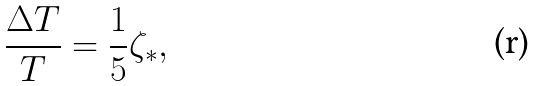<formula> <loc_0><loc_0><loc_500><loc_500>\frac { \Delta T } { T } = \frac { 1 } { 5 } \zeta _ { \ast } ,</formula> 